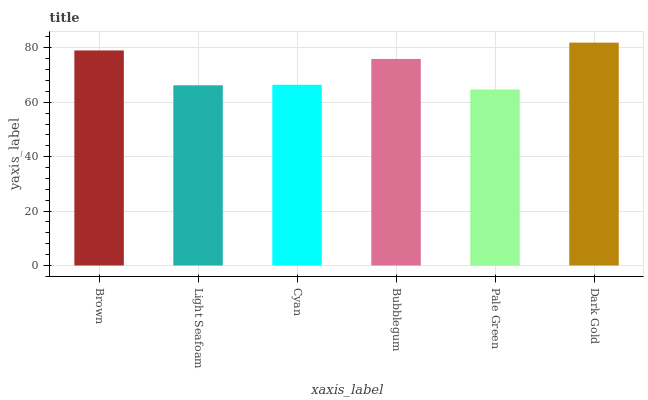Is Pale Green the minimum?
Answer yes or no. Yes. Is Dark Gold the maximum?
Answer yes or no. Yes. Is Light Seafoam the minimum?
Answer yes or no. No. Is Light Seafoam the maximum?
Answer yes or no. No. Is Brown greater than Light Seafoam?
Answer yes or no. Yes. Is Light Seafoam less than Brown?
Answer yes or no. Yes. Is Light Seafoam greater than Brown?
Answer yes or no. No. Is Brown less than Light Seafoam?
Answer yes or no. No. Is Bubblegum the high median?
Answer yes or no. Yes. Is Cyan the low median?
Answer yes or no. Yes. Is Cyan the high median?
Answer yes or no. No. Is Bubblegum the low median?
Answer yes or no. No. 